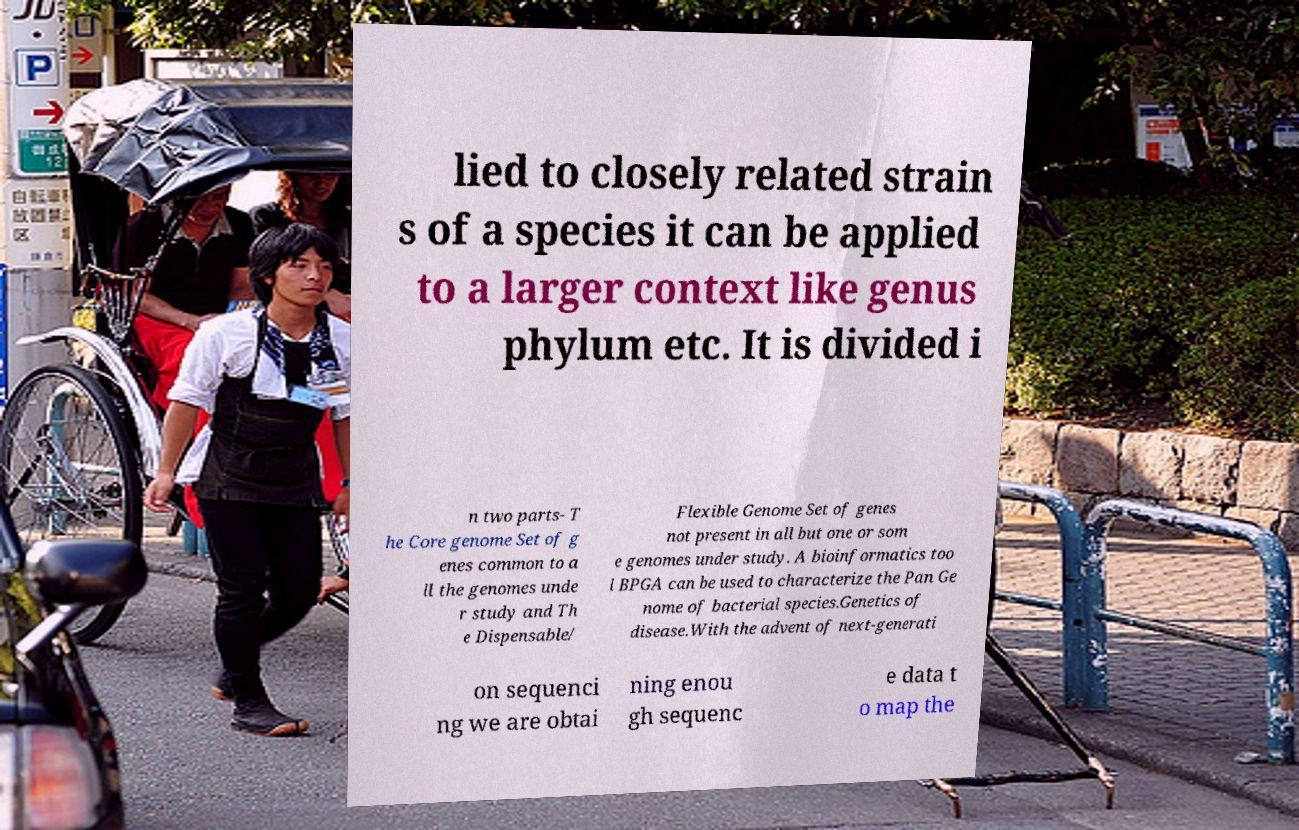Could you assist in decoding the text presented in this image and type it out clearly? lied to closely related strain s of a species it can be applied to a larger context like genus phylum etc. It is divided i n two parts- T he Core genome Set of g enes common to a ll the genomes unde r study and Th e Dispensable/ Flexible Genome Set of genes not present in all but one or som e genomes under study. A bioinformatics too l BPGA can be used to characterize the Pan Ge nome of bacterial species.Genetics of disease.With the advent of next-generati on sequenci ng we are obtai ning enou gh sequenc e data t o map the 